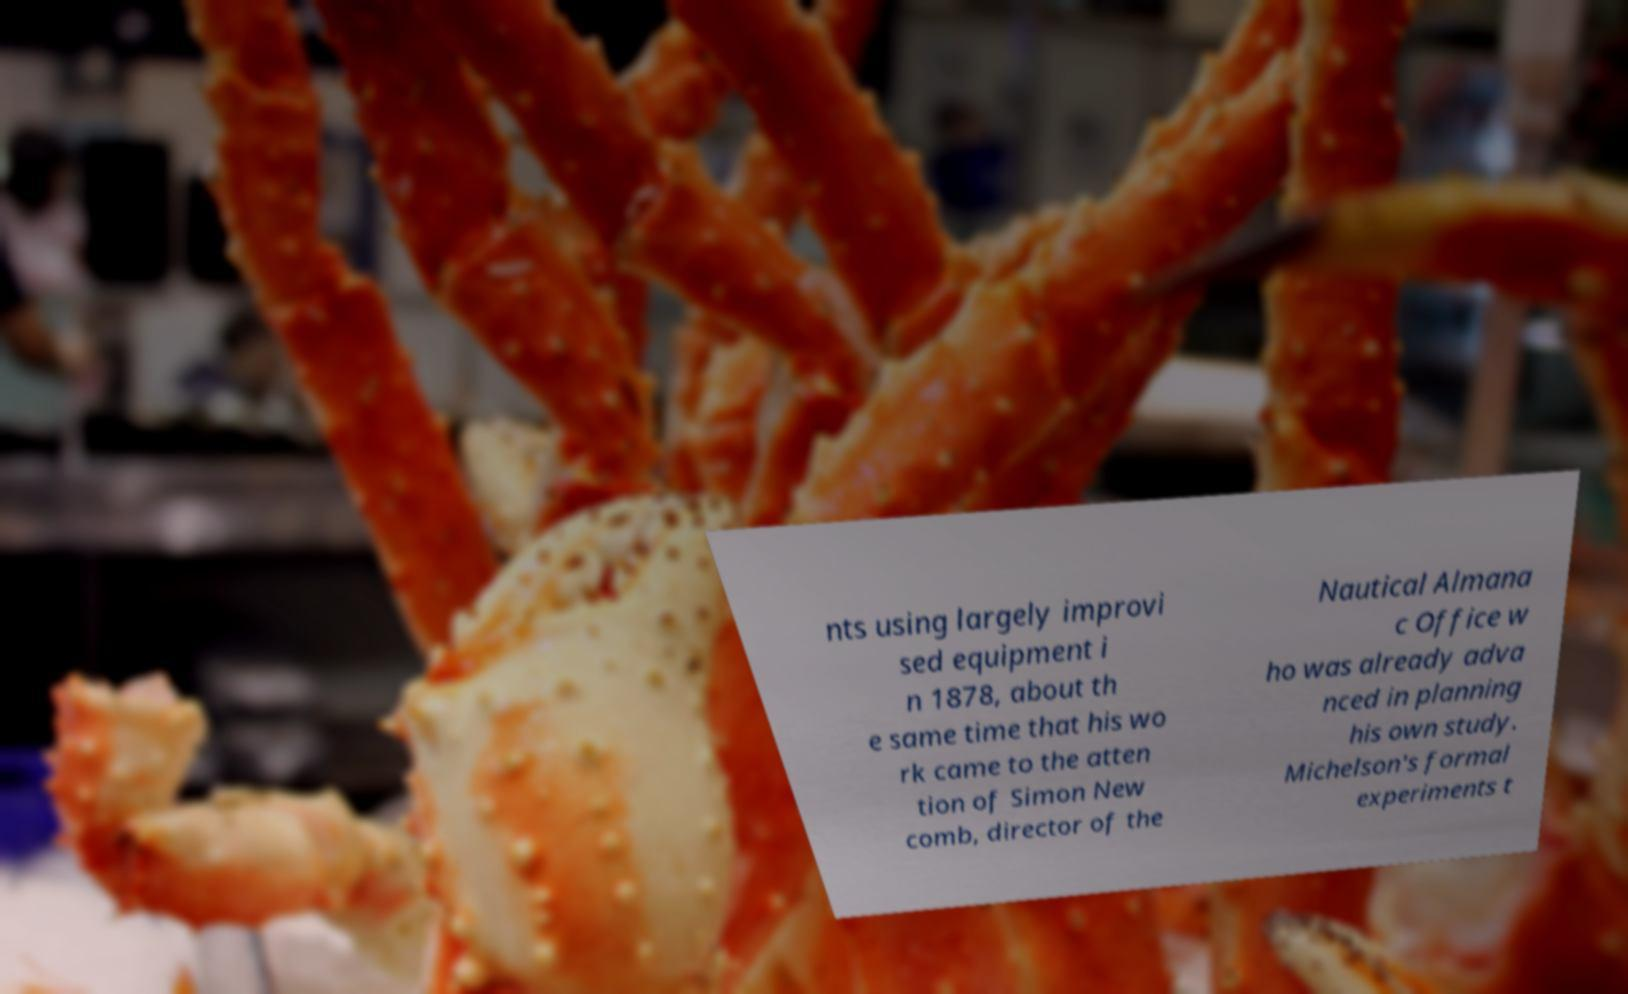There's text embedded in this image that I need extracted. Can you transcribe it verbatim? nts using largely improvi sed equipment i n 1878, about th e same time that his wo rk came to the atten tion of Simon New comb, director of the Nautical Almana c Office w ho was already adva nced in planning his own study. Michelson's formal experiments t 